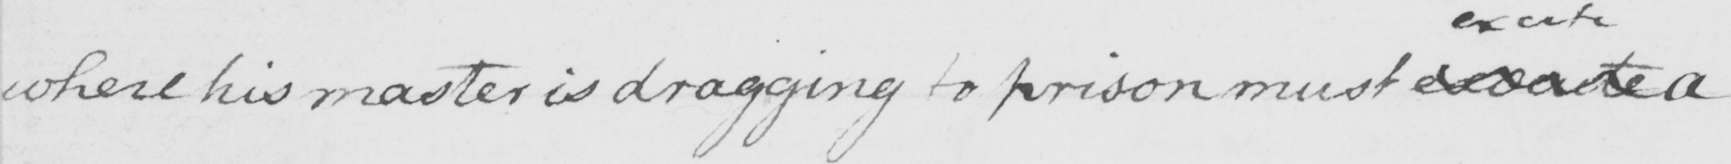Can you read and transcribe this handwriting? where his master is dragging to prison must  <gap/>  a 